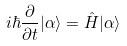Convert formula to latex. <formula><loc_0><loc_0><loc_500><loc_500>i \hbar { \frac { \partial } { \partial t } } | \alpha \rangle = { \hat { H } } | \alpha \rangle</formula> 